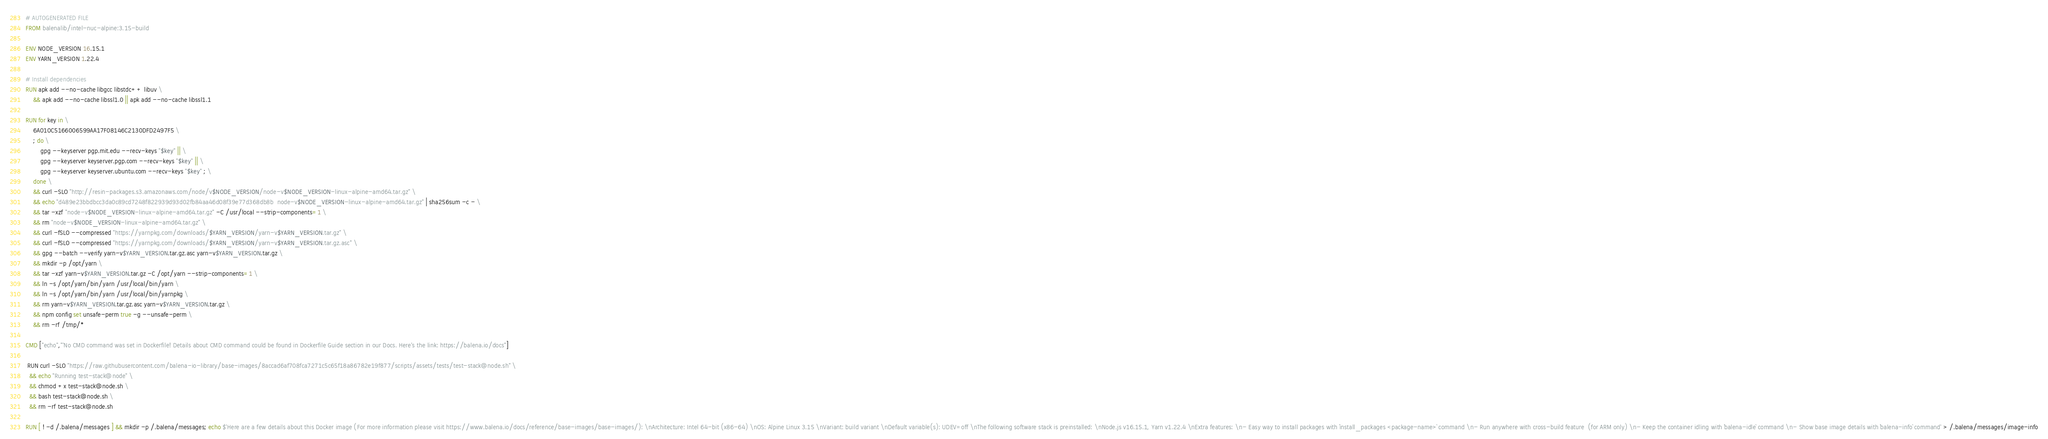Convert code to text. <code><loc_0><loc_0><loc_500><loc_500><_Dockerfile_># AUTOGENERATED FILE
FROM balenalib/intel-nuc-alpine:3.15-build

ENV NODE_VERSION 16.15.1
ENV YARN_VERSION 1.22.4

# Install dependencies
RUN apk add --no-cache libgcc libstdc++ libuv \
	&& apk add --no-cache libssl1.0 || apk add --no-cache libssl1.1

RUN for key in \
	6A010C5166006599AA17F08146C2130DFD2497F5 \
	; do \
		gpg --keyserver pgp.mit.edu --recv-keys "$key" || \
		gpg --keyserver keyserver.pgp.com --recv-keys "$key" || \
		gpg --keyserver keyserver.ubuntu.com --recv-keys "$key" ; \
	done \
	&& curl -SLO "http://resin-packages.s3.amazonaws.com/node/v$NODE_VERSION/node-v$NODE_VERSION-linux-alpine-amd64.tar.gz" \
	&& echo "d489e23bbdbcc3da0c89cd7248f822939d93d02fb84aa46d08f39e77d368db8b  node-v$NODE_VERSION-linux-alpine-amd64.tar.gz" | sha256sum -c - \
	&& tar -xzf "node-v$NODE_VERSION-linux-alpine-amd64.tar.gz" -C /usr/local --strip-components=1 \
	&& rm "node-v$NODE_VERSION-linux-alpine-amd64.tar.gz" \
	&& curl -fSLO --compressed "https://yarnpkg.com/downloads/$YARN_VERSION/yarn-v$YARN_VERSION.tar.gz" \
	&& curl -fSLO --compressed "https://yarnpkg.com/downloads/$YARN_VERSION/yarn-v$YARN_VERSION.tar.gz.asc" \
	&& gpg --batch --verify yarn-v$YARN_VERSION.tar.gz.asc yarn-v$YARN_VERSION.tar.gz \
	&& mkdir -p /opt/yarn \
	&& tar -xzf yarn-v$YARN_VERSION.tar.gz -C /opt/yarn --strip-components=1 \
	&& ln -s /opt/yarn/bin/yarn /usr/local/bin/yarn \
	&& ln -s /opt/yarn/bin/yarn /usr/local/bin/yarnpkg \
	&& rm yarn-v$YARN_VERSION.tar.gz.asc yarn-v$YARN_VERSION.tar.gz \
	&& npm config set unsafe-perm true -g --unsafe-perm \
	&& rm -rf /tmp/*

CMD ["echo","'No CMD command was set in Dockerfile! Details about CMD command could be found in Dockerfile Guide section in our Docs. Here's the link: https://balena.io/docs"]

 RUN curl -SLO "https://raw.githubusercontent.com/balena-io-library/base-images/8accad6af708fca7271c5c65f18a86782e19f877/scripts/assets/tests/test-stack@node.sh" \
  && echo "Running test-stack@node" \
  && chmod +x test-stack@node.sh \
  && bash test-stack@node.sh \
  && rm -rf test-stack@node.sh 

RUN [ ! -d /.balena/messages ] && mkdir -p /.balena/messages; echo $'Here are a few details about this Docker image (For more information please visit https://www.balena.io/docs/reference/base-images/base-images/): \nArchitecture: Intel 64-bit (x86-64) \nOS: Alpine Linux 3.15 \nVariant: build variant \nDefault variable(s): UDEV=off \nThe following software stack is preinstalled: \nNode.js v16.15.1, Yarn v1.22.4 \nExtra features: \n- Easy way to install packages with `install_packages <package-name>` command \n- Run anywhere with cross-build feature  (for ARM only) \n- Keep the container idling with `balena-idle` command \n- Show base image details with `balena-info` command' > /.balena/messages/image-info</code> 